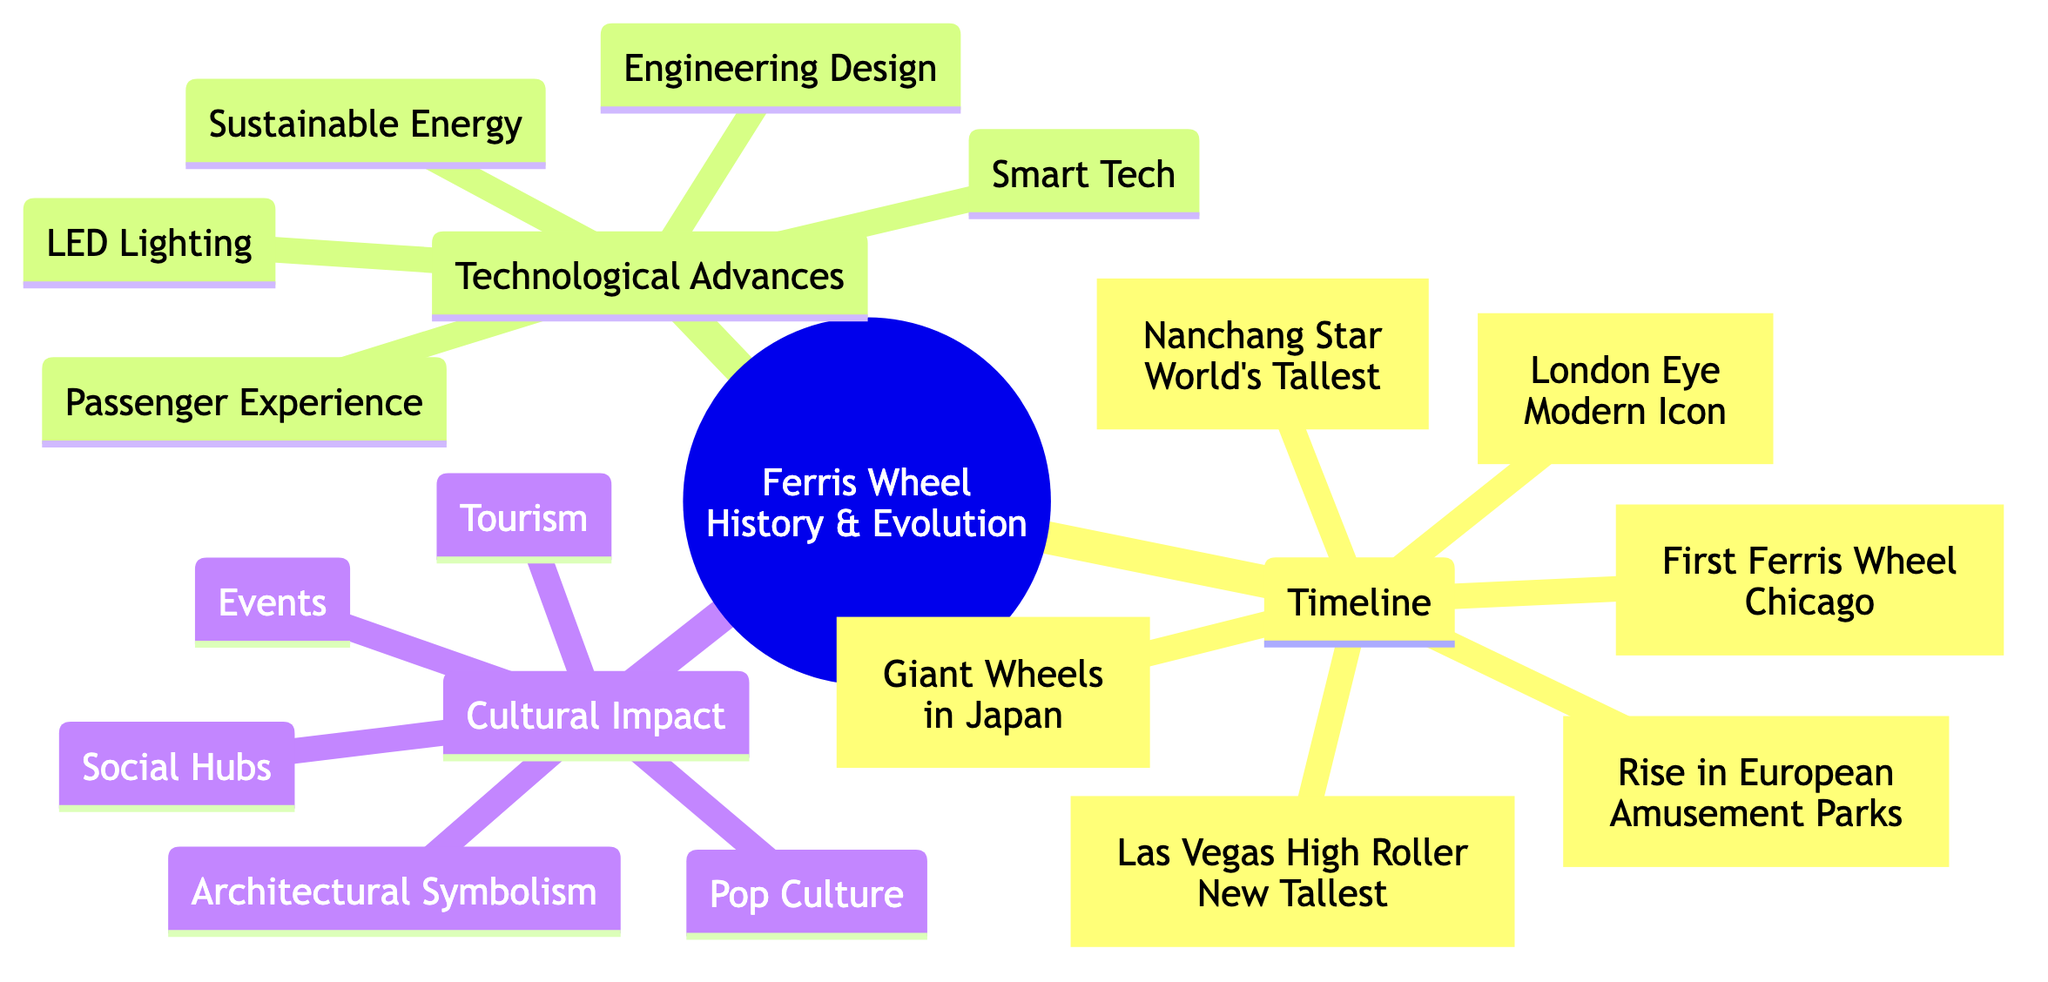What year was the first Ferris Wheel introduced? The diagram states that the first Ferris Wheel was introduced in 1893 by George Washington Gale Ferris Jr. at the World's Columbian Exposition in Chicago.
Answer: 1893 What is the modern icon Ferris Wheel mentioned in the timeline? According to the diagram, the London Eye was opened in 2000 and is referred to as a modern icon.
Answer: London Eye How many technological advances are listed? The diagram includes five technological advances under the respective category.
Answer: 5 Which Ferris Wheel became the world's tallest in 2006? The diagram explicitly states that the Nanchang Star in China became the world's tallest Ferris Wheel in 2006.
Answer: Nanchang Star What cultural impact relates to Ferris Wheels serving as gathering spots? The diagram categorizes this under "Social Hubs" as a cultural impact of Ferris Wheels.
Answer: Social Hubs What decade saw the rise of Ferris Wheels in European amusement parks? According to the timeline in the diagram, the rise of Ferris Wheels in European amusement parks occurred in the 1920s.
Answer: 1920s Which technological advancement relates to enhancing the viewing experience? The diagram mentions "Smart Tech," which includes integration with augmented reality to enhance the passenger viewing experience.
Answer: Smart Tech Which Ferris Wheel surpassed the Nanchang Star in height? The diagram indicates that the Las Vegas High Roller took the title of the world's tallest Ferris Wheel in 2014.
Answer: Las Vegas High Roller What is the relationship between Ferris Wheels and tourism as mentioned in the cultural impact section? The diagram states that Ferris Wheels are major tourist attractions worldwide, showing a direct connection between the two.
Answer: Major tourist attractions 